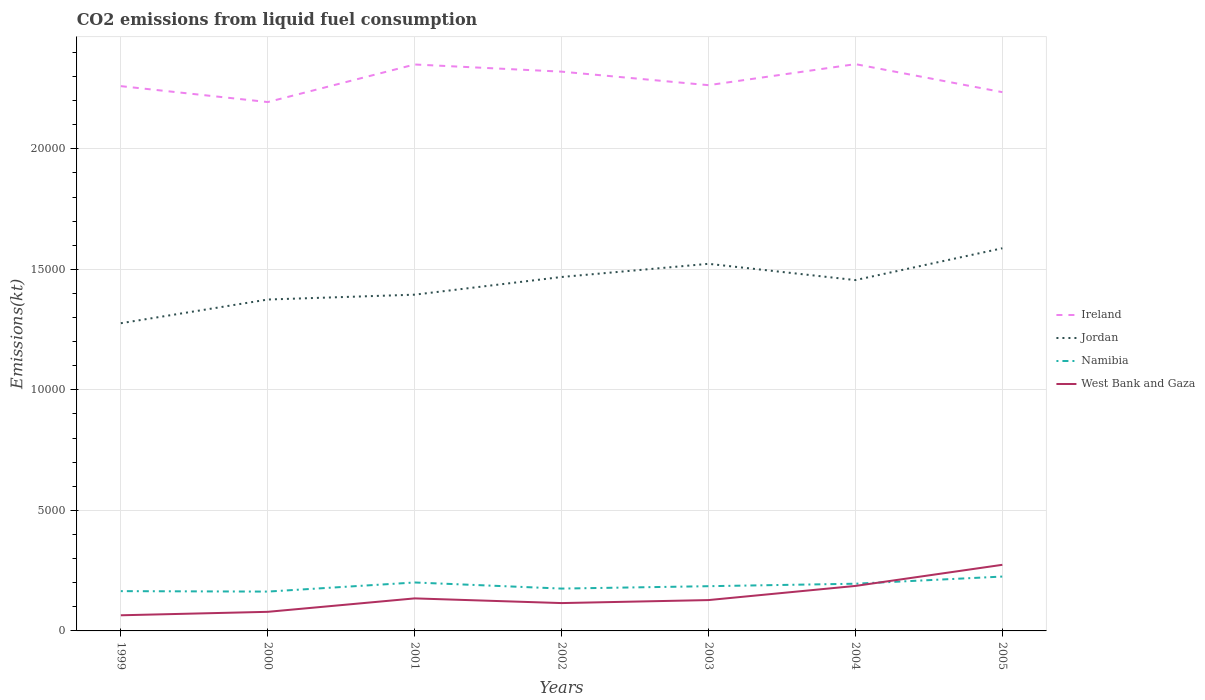How many different coloured lines are there?
Offer a terse response. 4. Does the line corresponding to Jordan intersect with the line corresponding to West Bank and Gaza?
Give a very brief answer. No. Across all years, what is the maximum amount of CO2 emitted in West Bank and Gaza?
Offer a very short reply. 649.06. In which year was the amount of CO2 emitted in Jordan maximum?
Offer a terse response. 1999. What is the total amount of CO2 emitted in Jordan in the graph?
Offer a terse response. -733.4. What is the difference between the highest and the second highest amount of CO2 emitted in Jordan?
Offer a very short reply. 3109.62. Is the amount of CO2 emitted in Namibia strictly greater than the amount of CO2 emitted in Jordan over the years?
Your answer should be compact. Yes. How many years are there in the graph?
Ensure brevity in your answer.  7. Where does the legend appear in the graph?
Offer a very short reply. Center right. How are the legend labels stacked?
Make the answer very short. Vertical. What is the title of the graph?
Ensure brevity in your answer.  CO2 emissions from liquid fuel consumption. What is the label or title of the X-axis?
Make the answer very short. Years. What is the label or title of the Y-axis?
Give a very brief answer. Emissions(kt). What is the Emissions(kt) in Ireland in 1999?
Offer a terse response. 2.26e+04. What is the Emissions(kt) in Jordan in 1999?
Your answer should be very brief. 1.28e+04. What is the Emissions(kt) in Namibia in 1999?
Ensure brevity in your answer.  1650.15. What is the Emissions(kt) in West Bank and Gaza in 1999?
Make the answer very short. 649.06. What is the Emissions(kt) in Ireland in 2000?
Give a very brief answer. 2.19e+04. What is the Emissions(kt) in Jordan in 2000?
Your answer should be very brief. 1.37e+04. What is the Emissions(kt) in Namibia in 2000?
Your answer should be very brief. 1631.82. What is the Emissions(kt) of West Bank and Gaza in 2000?
Give a very brief answer. 792.07. What is the Emissions(kt) in Ireland in 2001?
Provide a succinct answer. 2.35e+04. What is the Emissions(kt) in Jordan in 2001?
Offer a terse response. 1.39e+04. What is the Emissions(kt) of Namibia in 2001?
Give a very brief answer. 2009.52. What is the Emissions(kt) of West Bank and Gaza in 2001?
Offer a terse response. 1349.46. What is the Emissions(kt) of Ireland in 2002?
Provide a short and direct response. 2.32e+04. What is the Emissions(kt) in Jordan in 2002?
Your answer should be compact. 1.47e+04. What is the Emissions(kt) in Namibia in 2002?
Your answer should be compact. 1756.49. What is the Emissions(kt) of West Bank and Gaza in 2002?
Make the answer very short. 1155.11. What is the Emissions(kt) in Ireland in 2003?
Make the answer very short. 2.26e+04. What is the Emissions(kt) in Jordan in 2003?
Keep it short and to the point. 1.52e+04. What is the Emissions(kt) of Namibia in 2003?
Provide a short and direct response. 1855.5. What is the Emissions(kt) of West Bank and Gaza in 2003?
Your response must be concise. 1279.78. What is the Emissions(kt) of Ireland in 2004?
Offer a very short reply. 2.35e+04. What is the Emissions(kt) of Jordan in 2004?
Your answer should be compact. 1.46e+04. What is the Emissions(kt) in Namibia in 2004?
Your response must be concise. 1958.18. What is the Emissions(kt) of West Bank and Gaza in 2004?
Offer a very short reply. 1866.5. What is the Emissions(kt) of Ireland in 2005?
Provide a short and direct response. 2.24e+04. What is the Emissions(kt) of Jordan in 2005?
Ensure brevity in your answer.  1.59e+04. What is the Emissions(kt) of Namibia in 2005?
Keep it short and to the point. 2255.2. What is the Emissions(kt) in West Bank and Gaza in 2005?
Your response must be concise. 2742.92. Across all years, what is the maximum Emissions(kt) of Ireland?
Your response must be concise. 2.35e+04. Across all years, what is the maximum Emissions(kt) of Jordan?
Your answer should be very brief. 1.59e+04. Across all years, what is the maximum Emissions(kt) of Namibia?
Keep it short and to the point. 2255.2. Across all years, what is the maximum Emissions(kt) of West Bank and Gaza?
Your answer should be very brief. 2742.92. Across all years, what is the minimum Emissions(kt) in Ireland?
Offer a very short reply. 2.19e+04. Across all years, what is the minimum Emissions(kt) of Jordan?
Keep it short and to the point. 1.28e+04. Across all years, what is the minimum Emissions(kt) of Namibia?
Provide a succinct answer. 1631.82. Across all years, what is the minimum Emissions(kt) in West Bank and Gaza?
Your answer should be very brief. 649.06. What is the total Emissions(kt) of Ireland in the graph?
Provide a succinct answer. 1.60e+05. What is the total Emissions(kt) in Jordan in the graph?
Keep it short and to the point. 1.01e+05. What is the total Emissions(kt) of Namibia in the graph?
Ensure brevity in your answer.  1.31e+04. What is the total Emissions(kt) of West Bank and Gaza in the graph?
Your answer should be very brief. 9834.89. What is the difference between the Emissions(kt) of Ireland in 1999 and that in 2000?
Your response must be concise. 660.06. What is the difference between the Emissions(kt) in Jordan in 1999 and that in 2000?
Make the answer very short. -982.76. What is the difference between the Emissions(kt) in Namibia in 1999 and that in 2000?
Make the answer very short. 18.34. What is the difference between the Emissions(kt) of West Bank and Gaza in 1999 and that in 2000?
Offer a terse response. -143.01. What is the difference between the Emissions(kt) of Ireland in 1999 and that in 2001?
Ensure brevity in your answer.  -898.41. What is the difference between the Emissions(kt) in Jordan in 1999 and that in 2001?
Provide a succinct answer. -1184.44. What is the difference between the Emissions(kt) in Namibia in 1999 and that in 2001?
Offer a very short reply. -359.37. What is the difference between the Emissions(kt) of West Bank and Gaza in 1999 and that in 2001?
Ensure brevity in your answer.  -700.4. What is the difference between the Emissions(kt) of Ireland in 1999 and that in 2002?
Make the answer very short. -601.39. What is the difference between the Emissions(kt) of Jordan in 1999 and that in 2002?
Offer a very short reply. -1917.84. What is the difference between the Emissions(kt) of Namibia in 1999 and that in 2002?
Keep it short and to the point. -106.34. What is the difference between the Emissions(kt) of West Bank and Gaza in 1999 and that in 2002?
Your response must be concise. -506.05. What is the difference between the Emissions(kt) in Ireland in 1999 and that in 2003?
Make the answer very short. -40.34. What is the difference between the Emissions(kt) of Jordan in 1999 and that in 2003?
Offer a terse response. -2464.22. What is the difference between the Emissions(kt) of Namibia in 1999 and that in 2003?
Offer a terse response. -205.35. What is the difference between the Emissions(kt) of West Bank and Gaza in 1999 and that in 2003?
Offer a very short reply. -630.72. What is the difference between the Emissions(kt) in Ireland in 1999 and that in 2004?
Your response must be concise. -913.08. What is the difference between the Emissions(kt) of Jordan in 1999 and that in 2004?
Your answer should be compact. -1789.5. What is the difference between the Emissions(kt) of Namibia in 1999 and that in 2004?
Offer a terse response. -308.03. What is the difference between the Emissions(kt) of West Bank and Gaza in 1999 and that in 2004?
Ensure brevity in your answer.  -1217.44. What is the difference between the Emissions(kt) of Ireland in 1999 and that in 2005?
Your answer should be compact. 249.36. What is the difference between the Emissions(kt) in Jordan in 1999 and that in 2005?
Your answer should be very brief. -3109.62. What is the difference between the Emissions(kt) in Namibia in 1999 and that in 2005?
Make the answer very short. -605.05. What is the difference between the Emissions(kt) of West Bank and Gaza in 1999 and that in 2005?
Make the answer very short. -2093.86. What is the difference between the Emissions(kt) of Ireland in 2000 and that in 2001?
Offer a very short reply. -1558.47. What is the difference between the Emissions(kt) of Jordan in 2000 and that in 2001?
Your answer should be compact. -201.69. What is the difference between the Emissions(kt) of Namibia in 2000 and that in 2001?
Your answer should be compact. -377.7. What is the difference between the Emissions(kt) in West Bank and Gaza in 2000 and that in 2001?
Provide a succinct answer. -557.38. What is the difference between the Emissions(kt) in Ireland in 2000 and that in 2002?
Offer a terse response. -1261.45. What is the difference between the Emissions(kt) of Jordan in 2000 and that in 2002?
Provide a short and direct response. -935.09. What is the difference between the Emissions(kt) of Namibia in 2000 and that in 2002?
Offer a very short reply. -124.68. What is the difference between the Emissions(kt) in West Bank and Gaza in 2000 and that in 2002?
Ensure brevity in your answer.  -363.03. What is the difference between the Emissions(kt) in Ireland in 2000 and that in 2003?
Provide a succinct answer. -700.4. What is the difference between the Emissions(kt) in Jordan in 2000 and that in 2003?
Your response must be concise. -1481.47. What is the difference between the Emissions(kt) of Namibia in 2000 and that in 2003?
Keep it short and to the point. -223.69. What is the difference between the Emissions(kt) in West Bank and Gaza in 2000 and that in 2003?
Keep it short and to the point. -487.71. What is the difference between the Emissions(kt) in Ireland in 2000 and that in 2004?
Your answer should be very brief. -1573.14. What is the difference between the Emissions(kt) in Jordan in 2000 and that in 2004?
Keep it short and to the point. -806.74. What is the difference between the Emissions(kt) in Namibia in 2000 and that in 2004?
Provide a short and direct response. -326.36. What is the difference between the Emissions(kt) of West Bank and Gaza in 2000 and that in 2004?
Offer a very short reply. -1074.43. What is the difference between the Emissions(kt) in Ireland in 2000 and that in 2005?
Make the answer very short. -410.7. What is the difference between the Emissions(kt) in Jordan in 2000 and that in 2005?
Offer a terse response. -2126.86. What is the difference between the Emissions(kt) in Namibia in 2000 and that in 2005?
Your answer should be compact. -623.39. What is the difference between the Emissions(kt) of West Bank and Gaza in 2000 and that in 2005?
Offer a terse response. -1950.84. What is the difference between the Emissions(kt) in Ireland in 2001 and that in 2002?
Your response must be concise. 297.03. What is the difference between the Emissions(kt) in Jordan in 2001 and that in 2002?
Give a very brief answer. -733.4. What is the difference between the Emissions(kt) in Namibia in 2001 and that in 2002?
Keep it short and to the point. 253.02. What is the difference between the Emissions(kt) in West Bank and Gaza in 2001 and that in 2002?
Provide a succinct answer. 194.35. What is the difference between the Emissions(kt) in Ireland in 2001 and that in 2003?
Provide a succinct answer. 858.08. What is the difference between the Emissions(kt) in Jordan in 2001 and that in 2003?
Give a very brief answer. -1279.78. What is the difference between the Emissions(kt) of Namibia in 2001 and that in 2003?
Provide a succinct answer. 154.01. What is the difference between the Emissions(kt) in West Bank and Gaza in 2001 and that in 2003?
Give a very brief answer. 69.67. What is the difference between the Emissions(kt) in Ireland in 2001 and that in 2004?
Keep it short and to the point. -14.67. What is the difference between the Emissions(kt) in Jordan in 2001 and that in 2004?
Ensure brevity in your answer.  -605.05. What is the difference between the Emissions(kt) of Namibia in 2001 and that in 2004?
Your answer should be compact. 51.34. What is the difference between the Emissions(kt) in West Bank and Gaza in 2001 and that in 2004?
Provide a succinct answer. -517.05. What is the difference between the Emissions(kt) in Ireland in 2001 and that in 2005?
Keep it short and to the point. 1147.77. What is the difference between the Emissions(kt) in Jordan in 2001 and that in 2005?
Give a very brief answer. -1925.17. What is the difference between the Emissions(kt) of Namibia in 2001 and that in 2005?
Offer a very short reply. -245.69. What is the difference between the Emissions(kt) of West Bank and Gaza in 2001 and that in 2005?
Offer a very short reply. -1393.46. What is the difference between the Emissions(kt) in Ireland in 2002 and that in 2003?
Provide a succinct answer. 561.05. What is the difference between the Emissions(kt) of Jordan in 2002 and that in 2003?
Provide a succinct answer. -546.38. What is the difference between the Emissions(kt) in Namibia in 2002 and that in 2003?
Give a very brief answer. -99.01. What is the difference between the Emissions(kt) of West Bank and Gaza in 2002 and that in 2003?
Make the answer very short. -124.68. What is the difference between the Emissions(kt) of Ireland in 2002 and that in 2004?
Ensure brevity in your answer.  -311.69. What is the difference between the Emissions(kt) in Jordan in 2002 and that in 2004?
Provide a short and direct response. 128.34. What is the difference between the Emissions(kt) of Namibia in 2002 and that in 2004?
Your response must be concise. -201.69. What is the difference between the Emissions(kt) in West Bank and Gaza in 2002 and that in 2004?
Offer a terse response. -711.4. What is the difference between the Emissions(kt) of Ireland in 2002 and that in 2005?
Offer a terse response. 850.74. What is the difference between the Emissions(kt) of Jordan in 2002 and that in 2005?
Make the answer very short. -1191.78. What is the difference between the Emissions(kt) in Namibia in 2002 and that in 2005?
Your answer should be compact. -498.71. What is the difference between the Emissions(kt) in West Bank and Gaza in 2002 and that in 2005?
Your answer should be very brief. -1587.81. What is the difference between the Emissions(kt) of Ireland in 2003 and that in 2004?
Your answer should be very brief. -872.75. What is the difference between the Emissions(kt) of Jordan in 2003 and that in 2004?
Offer a very short reply. 674.73. What is the difference between the Emissions(kt) of Namibia in 2003 and that in 2004?
Offer a terse response. -102.68. What is the difference between the Emissions(kt) in West Bank and Gaza in 2003 and that in 2004?
Offer a very short reply. -586.72. What is the difference between the Emissions(kt) of Ireland in 2003 and that in 2005?
Offer a very short reply. 289.69. What is the difference between the Emissions(kt) in Jordan in 2003 and that in 2005?
Offer a very short reply. -645.39. What is the difference between the Emissions(kt) in Namibia in 2003 and that in 2005?
Give a very brief answer. -399.7. What is the difference between the Emissions(kt) of West Bank and Gaza in 2003 and that in 2005?
Provide a succinct answer. -1463.13. What is the difference between the Emissions(kt) in Ireland in 2004 and that in 2005?
Provide a short and direct response. 1162.44. What is the difference between the Emissions(kt) in Jordan in 2004 and that in 2005?
Give a very brief answer. -1320.12. What is the difference between the Emissions(kt) of Namibia in 2004 and that in 2005?
Offer a terse response. -297.03. What is the difference between the Emissions(kt) in West Bank and Gaza in 2004 and that in 2005?
Provide a succinct answer. -876.41. What is the difference between the Emissions(kt) in Ireland in 1999 and the Emissions(kt) in Jordan in 2000?
Ensure brevity in your answer.  8852.14. What is the difference between the Emissions(kt) in Ireland in 1999 and the Emissions(kt) in Namibia in 2000?
Provide a short and direct response. 2.10e+04. What is the difference between the Emissions(kt) of Ireland in 1999 and the Emissions(kt) of West Bank and Gaza in 2000?
Provide a short and direct response. 2.18e+04. What is the difference between the Emissions(kt) of Jordan in 1999 and the Emissions(kt) of Namibia in 2000?
Keep it short and to the point. 1.11e+04. What is the difference between the Emissions(kt) of Jordan in 1999 and the Emissions(kt) of West Bank and Gaza in 2000?
Your answer should be very brief. 1.20e+04. What is the difference between the Emissions(kt) in Namibia in 1999 and the Emissions(kt) in West Bank and Gaza in 2000?
Offer a terse response. 858.08. What is the difference between the Emissions(kt) of Ireland in 1999 and the Emissions(kt) of Jordan in 2001?
Provide a short and direct response. 8650.45. What is the difference between the Emissions(kt) of Ireland in 1999 and the Emissions(kt) of Namibia in 2001?
Provide a short and direct response. 2.06e+04. What is the difference between the Emissions(kt) in Ireland in 1999 and the Emissions(kt) in West Bank and Gaza in 2001?
Your answer should be very brief. 2.13e+04. What is the difference between the Emissions(kt) of Jordan in 1999 and the Emissions(kt) of Namibia in 2001?
Make the answer very short. 1.08e+04. What is the difference between the Emissions(kt) in Jordan in 1999 and the Emissions(kt) in West Bank and Gaza in 2001?
Offer a terse response. 1.14e+04. What is the difference between the Emissions(kt) in Namibia in 1999 and the Emissions(kt) in West Bank and Gaza in 2001?
Offer a terse response. 300.69. What is the difference between the Emissions(kt) of Ireland in 1999 and the Emissions(kt) of Jordan in 2002?
Offer a very short reply. 7917.05. What is the difference between the Emissions(kt) in Ireland in 1999 and the Emissions(kt) in Namibia in 2002?
Offer a very short reply. 2.08e+04. What is the difference between the Emissions(kt) in Ireland in 1999 and the Emissions(kt) in West Bank and Gaza in 2002?
Provide a succinct answer. 2.14e+04. What is the difference between the Emissions(kt) of Jordan in 1999 and the Emissions(kt) of Namibia in 2002?
Provide a succinct answer. 1.10e+04. What is the difference between the Emissions(kt) in Jordan in 1999 and the Emissions(kt) in West Bank and Gaza in 2002?
Offer a very short reply. 1.16e+04. What is the difference between the Emissions(kt) in Namibia in 1999 and the Emissions(kt) in West Bank and Gaza in 2002?
Keep it short and to the point. 495.05. What is the difference between the Emissions(kt) of Ireland in 1999 and the Emissions(kt) of Jordan in 2003?
Offer a very short reply. 7370.67. What is the difference between the Emissions(kt) in Ireland in 1999 and the Emissions(kt) in Namibia in 2003?
Keep it short and to the point. 2.07e+04. What is the difference between the Emissions(kt) of Ireland in 1999 and the Emissions(kt) of West Bank and Gaza in 2003?
Your response must be concise. 2.13e+04. What is the difference between the Emissions(kt) of Jordan in 1999 and the Emissions(kt) of Namibia in 2003?
Provide a succinct answer. 1.09e+04. What is the difference between the Emissions(kt) of Jordan in 1999 and the Emissions(kt) of West Bank and Gaza in 2003?
Make the answer very short. 1.15e+04. What is the difference between the Emissions(kt) of Namibia in 1999 and the Emissions(kt) of West Bank and Gaza in 2003?
Ensure brevity in your answer.  370.37. What is the difference between the Emissions(kt) of Ireland in 1999 and the Emissions(kt) of Jordan in 2004?
Make the answer very short. 8045.4. What is the difference between the Emissions(kt) of Ireland in 1999 and the Emissions(kt) of Namibia in 2004?
Offer a terse response. 2.06e+04. What is the difference between the Emissions(kt) in Ireland in 1999 and the Emissions(kt) in West Bank and Gaza in 2004?
Provide a succinct answer. 2.07e+04. What is the difference between the Emissions(kt) of Jordan in 1999 and the Emissions(kt) of Namibia in 2004?
Your answer should be compact. 1.08e+04. What is the difference between the Emissions(kt) of Jordan in 1999 and the Emissions(kt) of West Bank and Gaza in 2004?
Provide a succinct answer. 1.09e+04. What is the difference between the Emissions(kt) in Namibia in 1999 and the Emissions(kt) in West Bank and Gaza in 2004?
Ensure brevity in your answer.  -216.35. What is the difference between the Emissions(kt) of Ireland in 1999 and the Emissions(kt) of Jordan in 2005?
Keep it short and to the point. 6725.28. What is the difference between the Emissions(kt) of Ireland in 1999 and the Emissions(kt) of Namibia in 2005?
Ensure brevity in your answer.  2.03e+04. What is the difference between the Emissions(kt) of Ireland in 1999 and the Emissions(kt) of West Bank and Gaza in 2005?
Keep it short and to the point. 1.99e+04. What is the difference between the Emissions(kt) in Jordan in 1999 and the Emissions(kt) in Namibia in 2005?
Your answer should be very brief. 1.05e+04. What is the difference between the Emissions(kt) of Jordan in 1999 and the Emissions(kt) of West Bank and Gaza in 2005?
Ensure brevity in your answer.  1.00e+04. What is the difference between the Emissions(kt) of Namibia in 1999 and the Emissions(kt) of West Bank and Gaza in 2005?
Provide a succinct answer. -1092.77. What is the difference between the Emissions(kt) in Ireland in 2000 and the Emissions(kt) in Jordan in 2001?
Your response must be concise. 7990.39. What is the difference between the Emissions(kt) of Ireland in 2000 and the Emissions(kt) of Namibia in 2001?
Offer a very short reply. 1.99e+04. What is the difference between the Emissions(kt) in Ireland in 2000 and the Emissions(kt) in West Bank and Gaza in 2001?
Ensure brevity in your answer.  2.06e+04. What is the difference between the Emissions(kt) in Jordan in 2000 and the Emissions(kt) in Namibia in 2001?
Give a very brief answer. 1.17e+04. What is the difference between the Emissions(kt) of Jordan in 2000 and the Emissions(kt) of West Bank and Gaza in 2001?
Ensure brevity in your answer.  1.24e+04. What is the difference between the Emissions(kt) of Namibia in 2000 and the Emissions(kt) of West Bank and Gaza in 2001?
Ensure brevity in your answer.  282.36. What is the difference between the Emissions(kt) of Ireland in 2000 and the Emissions(kt) of Jordan in 2002?
Provide a short and direct response. 7256.99. What is the difference between the Emissions(kt) in Ireland in 2000 and the Emissions(kt) in Namibia in 2002?
Keep it short and to the point. 2.02e+04. What is the difference between the Emissions(kt) in Ireland in 2000 and the Emissions(kt) in West Bank and Gaza in 2002?
Your answer should be compact. 2.08e+04. What is the difference between the Emissions(kt) of Jordan in 2000 and the Emissions(kt) of Namibia in 2002?
Give a very brief answer. 1.20e+04. What is the difference between the Emissions(kt) of Jordan in 2000 and the Emissions(kt) of West Bank and Gaza in 2002?
Offer a terse response. 1.26e+04. What is the difference between the Emissions(kt) in Namibia in 2000 and the Emissions(kt) in West Bank and Gaza in 2002?
Make the answer very short. 476.71. What is the difference between the Emissions(kt) of Ireland in 2000 and the Emissions(kt) of Jordan in 2003?
Offer a terse response. 6710.61. What is the difference between the Emissions(kt) in Ireland in 2000 and the Emissions(kt) in Namibia in 2003?
Give a very brief answer. 2.01e+04. What is the difference between the Emissions(kt) in Ireland in 2000 and the Emissions(kt) in West Bank and Gaza in 2003?
Give a very brief answer. 2.07e+04. What is the difference between the Emissions(kt) in Jordan in 2000 and the Emissions(kt) in Namibia in 2003?
Give a very brief answer. 1.19e+04. What is the difference between the Emissions(kt) of Jordan in 2000 and the Emissions(kt) of West Bank and Gaza in 2003?
Provide a short and direct response. 1.25e+04. What is the difference between the Emissions(kt) in Namibia in 2000 and the Emissions(kt) in West Bank and Gaza in 2003?
Offer a very short reply. 352.03. What is the difference between the Emissions(kt) in Ireland in 2000 and the Emissions(kt) in Jordan in 2004?
Provide a succinct answer. 7385.34. What is the difference between the Emissions(kt) of Ireland in 2000 and the Emissions(kt) of Namibia in 2004?
Your answer should be compact. 2.00e+04. What is the difference between the Emissions(kt) of Ireland in 2000 and the Emissions(kt) of West Bank and Gaza in 2004?
Give a very brief answer. 2.01e+04. What is the difference between the Emissions(kt) of Jordan in 2000 and the Emissions(kt) of Namibia in 2004?
Provide a short and direct response. 1.18e+04. What is the difference between the Emissions(kt) in Jordan in 2000 and the Emissions(kt) in West Bank and Gaza in 2004?
Provide a succinct answer. 1.19e+04. What is the difference between the Emissions(kt) in Namibia in 2000 and the Emissions(kt) in West Bank and Gaza in 2004?
Offer a very short reply. -234.69. What is the difference between the Emissions(kt) in Ireland in 2000 and the Emissions(kt) in Jordan in 2005?
Ensure brevity in your answer.  6065.22. What is the difference between the Emissions(kt) of Ireland in 2000 and the Emissions(kt) of Namibia in 2005?
Keep it short and to the point. 1.97e+04. What is the difference between the Emissions(kt) of Ireland in 2000 and the Emissions(kt) of West Bank and Gaza in 2005?
Give a very brief answer. 1.92e+04. What is the difference between the Emissions(kt) in Jordan in 2000 and the Emissions(kt) in Namibia in 2005?
Your answer should be compact. 1.15e+04. What is the difference between the Emissions(kt) of Jordan in 2000 and the Emissions(kt) of West Bank and Gaza in 2005?
Your answer should be compact. 1.10e+04. What is the difference between the Emissions(kt) in Namibia in 2000 and the Emissions(kt) in West Bank and Gaza in 2005?
Make the answer very short. -1111.1. What is the difference between the Emissions(kt) in Ireland in 2001 and the Emissions(kt) in Jordan in 2002?
Make the answer very short. 8815.47. What is the difference between the Emissions(kt) in Ireland in 2001 and the Emissions(kt) in Namibia in 2002?
Your answer should be very brief. 2.17e+04. What is the difference between the Emissions(kt) of Ireland in 2001 and the Emissions(kt) of West Bank and Gaza in 2002?
Offer a terse response. 2.23e+04. What is the difference between the Emissions(kt) in Jordan in 2001 and the Emissions(kt) in Namibia in 2002?
Your answer should be very brief. 1.22e+04. What is the difference between the Emissions(kt) in Jordan in 2001 and the Emissions(kt) in West Bank and Gaza in 2002?
Your answer should be very brief. 1.28e+04. What is the difference between the Emissions(kt) in Namibia in 2001 and the Emissions(kt) in West Bank and Gaza in 2002?
Provide a short and direct response. 854.41. What is the difference between the Emissions(kt) in Ireland in 2001 and the Emissions(kt) in Jordan in 2003?
Give a very brief answer. 8269.08. What is the difference between the Emissions(kt) of Ireland in 2001 and the Emissions(kt) of Namibia in 2003?
Give a very brief answer. 2.16e+04. What is the difference between the Emissions(kt) of Ireland in 2001 and the Emissions(kt) of West Bank and Gaza in 2003?
Your answer should be compact. 2.22e+04. What is the difference between the Emissions(kt) of Jordan in 2001 and the Emissions(kt) of Namibia in 2003?
Ensure brevity in your answer.  1.21e+04. What is the difference between the Emissions(kt) of Jordan in 2001 and the Emissions(kt) of West Bank and Gaza in 2003?
Keep it short and to the point. 1.27e+04. What is the difference between the Emissions(kt) in Namibia in 2001 and the Emissions(kt) in West Bank and Gaza in 2003?
Offer a terse response. 729.73. What is the difference between the Emissions(kt) in Ireland in 2001 and the Emissions(kt) in Jordan in 2004?
Your answer should be compact. 8943.81. What is the difference between the Emissions(kt) of Ireland in 2001 and the Emissions(kt) of Namibia in 2004?
Make the answer very short. 2.15e+04. What is the difference between the Emissions(kt) in Ireland in 2001 and the Emissions(kt) in West Bank and Gaza in 2004?
Your response must be concise. 2.16e+04. What is the difference between the Emissions(kt) of Jordan in 2001 and the Emissions(kt) of Namibia in 2004?
Your answer should be compact. 1.20e+04. What is the difference between the Emissions(kt) of Jordan in 2001 and the Emissions(kt) of West Bank and Gaza in 2004?
Your answer should be very brief. 1.21e+04. What is the difference between the Emissions(kt) of Namibia in 2001 and the Emissions(kt) of West Bank and Gaza in 2004?
Give a very brief answer. 143.01. What is the difference between the Emissions(kt) of Ireland in 2001 and the Emissions(kt) of Jordan in 2005?
Your answer should be compact. 7623.69. What is the difference between the Emissions(kt) in Ireland in 2001 and the Emissions(kt) in Namibia in 2005?
Keep it short and to the point. 2.12e+04. What is the difference between the Emissions(kt) in Ireland in 2001 and the Emissions(kt) in West Bank and Gaza in 2005?
Your answer should be very brief. 2.08e+04. What is the difference between the Emissions(kt) of Jordan in 2001 and the Emissions(kt) of Namibia in 2005?
Your answer should be compact. 1.17e+04. What is the difference between the Emissions(kt) in Jordan in 2001 and the Emissions(kt) in West Bank and Gaza in 2005?
Give a very brief answer. 1.12e+04. What is the difference between the Emissions(kt) in Namibia in 2001 and the Emissions(kt) in West Bank and Gaza in 2005?
Provide a short and direct response. -733.4. What is the difference between the Emissions(kt) of Ireland in 2002 and the Emissions(kt) of Jordan in 2003?
Your answer should be very brief. 7972.06. What is the difference between the Emissions(kt) of Ireland in 2002 and the Emissions(kt) of Namibia in 2003?
Offer a terse response. 2.13e+04. What is the difference between the Emissions(kt) in Ireland in 2002 and the Emissions(kt) in West Bank and Gaza in 2003?
Provide a succinct answer. 2.19e+04. What is the difference between the Emissions(kt) in Jordan in 2002 and the Emissions(kt) in Namibia in 2003?
Ensure brevity in your answer.  1.28e+04. What is the difference between the Emissions(kt) in Jordan in 2002 and the Emissions(kt) in West Bank and Gaza in 2003?
Give a very brief answer. 1.34e+04. What is the difference between the Emissions(kt) in Namibia in 2002 and the Emissions(kt) in West Bank and Gaza in 2003?
Give a very brief answer. 476.71. What is the difference between the Emissions(kt) in Ireland in 2002 and the Emissions(kt) in Jordan in 2004?
Your response must be concise. 8646.79. What is the difference between the Emissions(kt) of Ireland in 2002 and the Emissions(kt) of Namibia in 2004?
Your answer should be compact. 2.12e+04. What is the difference between the Emissions(kt) in Ireland in 2002 and the Emissions(kt) in West Bank and Gaza in 2004?
Give a very brief answer. 2.13e+04. What is the difference between the Emissions(kt) of Jordan in 2002 and the Emissions(kt) of Namibia in 2004?
Offer a terse response. 1.27e+04. What is the difference between the Emissions(kt) of Jordan in 2002 and the Emissions(kt) of West Bank and Gaza in 2004?
Give a very brief answer. 1.28e+04. What is the difference between the Emissions(kt) of Namibia in 2002 and the Emissions(kt) of West Bank and Gaza in 2004?
Ensure brevity in your answer.  -110.01. What is the difference between the Emissions(kt) in Ireland in 2002 and the Emissions(kt) in Jordan in 2005?
Give a very brief answer. 7326.67. What is the difference between the Emissions(kt) in Ireland in 2002 and the Emissions(kt) in Namibia in 2005?
Provide a short and direct response. 2.09e+04. What is the difference between the Emissions(kt) of Ireland in 2002 and the Emissions(kt) of West Bank and Gaza in 2005?
Offer a very short reply. 2.05e+04. What is the difference between the Emissions(kt) in Jordan in 2002 and the Emissions(kt) in Namibia in 2005?
Ensure brevity in your answer.  1.24e+04. What is the difference between the Emissions(kt) in Jordan in 2002 and the Emissions(kt) in West Bank and Gaza in 2005?
Make the answer very short. 1.19e+04. What is the difference between the Emissions(kt) in Namibia in 2002 and the Emissions(kt) in West Bank and Gaza in 2005?
Ensure brevity in your answer.  -986.42. What is the difference between the Emissions(kt) of Ireland in 2003 and the Emissions(kt) of Jordan in 2004?
Your answer should be very brief. 8085.73. What is the difference between the Emissions(kt) in Ireland in 2003 and the Emissions(kt) in Namibia in 2004?
Offer a terse response. 2.07e+04. What is the difference between the Emissions(kt) of Ireland in 2003 and the Emissions(kt) of West Bank and Gaza in 2004?
Provide a short and direct response. 2.08e+04. What is the difference between the Emissions(kt) in Jordan in 2003 and the Emissions(kt) in Namibia in 2004?
Your answer should be compact. 1.33e+04. What is the difference between the Emissions(kt) in Jordan in 2003 and the Emissions(kt) in West Bank and Gaza in 2004?
Offer a very short reply. 1.34e+04. What is the difference between the Emissions(kt) in Namibia in 2003 and the Emissions(kt) in West Bank and Gaza in 2004?
Offer a terse response. -11. What is the difference between the Emissions(kt) of Ireland in 2003 and the Emissions(kt) of Jordan in 2005?
Provide a succinct answer. 6765.61. What is the difference between the Emissions(kt) of Ireland in 2003 and the Emissions(kt) of Namibia in 2005?
Give a very brief answer. 2.04e+04. What is the difference between the Emissions(kt) in Ireland in 2003 and the Emissions(kt) in West Bank and Gaza in 2005?
Your response must be concise. 1.99e+04. What is the difference between the Emissions(kt) of Jordan in 2003 and the Emissions(kt) of Namibia in 2005?
Provide a short and direct response. 1.30e+04. What is the difference between the Emissions(kt) of Jordan in 2003 and the Emissions(kt) of West Bank and Gaza in 2005?
Your answer should be very brief. 1.25e+04. What is the difference between the Emissions(kt) of Namibia in 2003 and the Emissions(kt) of West Bank and Gaza in 2005?
Provide a short and direct response. -887.41. What is the difference between the Emissions(kt) of Ireland in 2004 and the Emissions(kt) of Jordan in 2005?
Provide a short and direct response. 7638.36. What is the difference between the Emissions(kt) of Ireland in 2004 and the Emissions(kt) of Namibia in 2005?
Keep it short and to the point. 2.13e+04. What is the difference between the Emissions(kt) of Ireland in 2004 and the Emissions(kt) of West Bank and Gaza in 2005?
Offer a terse response. 2.08e+04. What is the difference between the Emissions(kt) in Jordan in 2004 and the Emissions(kt) in Namibia in 2005?
Provide a succinct answer. 1.23e+04. What is the difference between the Emissions(kt) of Jordan in 2004 and the Emissions(kt) of West Bank and Gaza in 2005?
Ensure brevity in your answer.  1.18e+04. What is the difference between the Emissions(kt) in Namibia in 2004 and the Emissions(kt) in West Bank and Gaza in 2005?
Provide a short and direct response. -784.74. What is the average Emissions(kt) in Ireland per year?
Provide a short and direct response. 2.28e+04. What is the average Emissions(kt) of Jordan per year?
Your response must be concise. 1.44e+04. What is the average Emissions(kt) of Namibia per year?
Offer a very short reply. 1873.84. What is the average Emissions(kt) of West Bank and Gaza per year?
Offer a very short reply. 1404.98. In the year 1999, what is the difference between the Emissions(kt) of Ireland and Emissions(kt) of Jordan?
Your answer should be very brief. 9834.89. In the year 1999, what is the difference between the Emissions(kt) of Ireland and Emissions(kt) of Namibia?
Give a very brief answer. 2.09e+04. In the year 1999, what is the difference between the Emissions(kt) of Ireland and Emissions(kt) of West Bank and Gaza?
Offer a very short reply. 2.20e+04. In the year 1999, what is the difference between the Emissions(kt) in Jordan and Emissions(kt) in Namibia?
Your answer should be very brief. 1.11e+04. In the year 1999, what is the difference between the Emissions(kt) in Jordan and Emissions(kt) in West Bank and Gaza?
Give a very brief answer. 1.21e+04. In the year 1999, what is the difference between the Emissions(kt) of Namibia and Emissions(kt) of West Bank and Gaza?
Your response must be concise. 1001.09. In the year 2000, what is the difference between the Emissions(kt) in Ireland and Emissions(kt) in Jordan?
Ensure brevity in your answer.  8192.08. In the year 2000, what is the difference between the Emissions(kt) in Ireland and Emissions(kt) in Namibia?
Your response must be concise. 2.03e+04. In the year 2000, what is the difference between the Emissions(kt) in Ireland and Emissions(kt) in West Bank and Gaza?
Ensure brevity in your answer.  2.11e+04. In the year 2000, what is the difference between the Emissions(kt) in Jordan and Emissions(kt) in Namibia?
Keep it short and to the point. 1.21e+04. In the year 2000, what is the difference between the Emissions(kt) in Jordan and Emissions(kt) in West Bank and Gaza?
Provide a short and direct response. 1.30e+04. In the year 2000, what is the difference between the Emissions(kt) of Namibia and Emissions(kt) of West Bank and Gaza?
Provide a succinct answer. 839.74. In the year 2001, what is the difference between the Emissions(kt) in Ireland and Emissions(kt) in Jordan?
Your response must be concise. 9548.87. In the year 2001, what is the difference between the Emissions(kt) of Ireland and Emissions(kt) of Namibia?
Your answer should be very brief. 2.15e+04. In the year 2001, what is the difference between the Emissions(kt) in Ireland and Emissions(kt) in West Bank and Gaza?
Give a very brief answer. 2.21e+04. In the year 2001, what is the difference between the Emissions(kt) of Jordan and Emissions(kt) of Namibia?
Offer a terse response. 1.19e+04. In the year 2001, what is the difference between the Emissions(kt) of Jordan and Emissions(kt) of West Bank and Gaza?
Provide a short and direct response. 1.26e+04. In the year 2001, what is the difference between the Emissions(kt) of Namibia and Emissions(kt) of West Bank and Gaza?
Ensure brevity in your answer.  660.06. In the year 2002, what is the difference between the Emissions(kt) in Ireland and Emissions(kt) in Jordan?
Ensure brevity in your answer.  8518.44. In the year 2002, what is the difference between the Emissions(kt) in Ireland and Emissions(kt) in Namibia?
Offer a terse response. 2.14e+04. In the year 2002, what is the difference between the Emissions(kt) of Ireland and Emissions(kt) of West Bank and Gaza?
Ensure brevity in your answer.  2.20e+04. In the year 2002, what is the difference between the Emissions(kt) of Jordan and Emissions(kt) of Namibia?
Make the answer very short. 1.29e+04. In the year 2002, what is the difference between the Emissions(kt) of Jordan and Emissions(kt) of West Bank and Gaza?
Your response must be concise. 1.35e+04. In the year 2002, what is the difference between the Emissions(kt) of Namibia and Emissions(kt) of West Bank and Gaza?
Ensure brevity in your answer.  601.39. In the year 2003, what is the difference between the Emissions(kt) of Ireland and Emissions(kt) of Jordan?
Provide a short and direct response. 7411.01. In the year 2003, what is the difference between the Emissions(kt) in Ireland and Emissions(kt) in Namibia?
Keep it short and to the point. 2.08e+04. In the year 2003, what is the difference between the Emissions(kt) of Ireland and Emissions(kt) of West Bank and Gaza?
Your answer should be very brief. 2.14e+04. In the year 2003, what is the difference between the Emissions(kt) in Jordan and Emissions(kt) in Namibia?
Offer a terse response. 1.34e+04. In the year 2003, what is the difference between the Emissions(kt) of Jordan and Emissions(kt) of West Bank and Gaza?
Your answer should be compact. 1.39e+04. In the year 2003, what is the difference between the Emissions(kt) of Namibia and Emissions(kt) of West Bank and Gaza?
Provide a short and direct response. 575.72. In the year 2004, what is the difference between the Emissions(kt) in Ireland and Emissions(kt) in Jordan?
Provide a succinct answer. 8958.48. In the year 2004, what is the difference between the Emissions(kt) in Ireland and Emissions(kt) in Namibia?
Your answer should be compact. 2.16e+04. In the year 2004, what is the difference between the Emissions(kt) of Ireland and Emissions(kt) of West Bank and Gaza?
Your answer should be compact. 2.16e+04. In the year 2004, what is the difference between the Emissions(kt) of Jordan and Emissions(kt) of Namibia?
Your answer should be compact. 1.26e+04. In the year 2004, what is the difference between the Emissions(kt) of Jordan and Emissions(kt) of West Bank and Gaza?
Offer a very short reply. 1.27e+04. In the year 2004, what is the difference between the Emissions(kt) in Namibia and Emissions(kt) in West Bank and Gaza?
Your answer should be compact. 91.67. In the year 2005, what is the difference between the Emissions(kt) in Ireland and Emissions(kt) in Jordan?
Make the answer very short. 6475.92. In the year 2005, what is the difference between the Emissions(kt) of Ireland and Emissions(kt) of Namibia?
Provide a succinct answer. 2.01e+04. In the year 2005, what is the difference between the Emissions(kt) in Ireland and Emissions(kt) in West Bank and Gaza?
Your answer should be very brief. 1.96e+04. In the year 2005, what is the difference between the Emissions(kt) in Jordan and Emissions(kt) in Namibia?
Provide a succinct answer. 1.36e+04. In the year 2005, what is the difference between the Emissions(kt) in Jordan and Emissions(kt) in West Bank and Gaza?
Provide a succinct answer. 1.31e+04. In the year 2005, what is the difference between the Emissions(kt) of Namibia and Emissions(kt) of West Bank and Gaza?
Your answer should be compact. -487.71. What is the ratio of the Emissions(kt) of Ireland in 1999 to that in 2000?
Provide a short and direct response. 1.03. What is the ratio of the Emissions(kt) in Jordan in 1999 to that in 2000?
Keep it short and to the point. 0.93. What is the ratio of the Emissions(kt) of Namibia in 1999 to that in 2000?
Ensure brevity in your answer.  1.01. What is the ratio of the Emissions(kt) in West Bank and Gaza in 1999 to that in 2000?
Your answer should be very brief. 0.82. What is the ratio of the Emissions(kt) of Ireland in 1999 to that in 2001?
Make the answer very short. 0.96. What is the ratio of the Emissions(kt) of Jordan in 1999 to that in 2001?
Provide a short and direct response. 0.92. What is the ratio of the Emissions(kt) in Namibia in 1999 to that in 2001?
Your answer should be compact. 0.82. What is the ratio of the Emissions(kt) in West Bank and Gaza in 1999 to that in 2001?
Your response must be concise. 0.48. What is the ratio of the Emissions(kt) in Ireland in 1999 to that in 2002?
Your response must be concise. 0.97. What is the ratio of the Emissions(kt) in Jordan in 1999 to that in 2002?
Keep it short and to the point. 0.87. What is the ratio of the Emissions(kt) in Namibia in 1999 to that in 2002?
Offer a terse response. 0.94. What is the ratio of the Emissions(kt) of West Bank and Gaza in 1999 to that in 2002?
Make the answer very short. 0.56. What is the ratio of the Emissions(kt) in Ireland in 1999 to that in 2003?
Keep it short and to the point. 1. What is the ratio of the Emissions(kt) in Jordan in 1999 to that in 2003?
Offer a very short reply. 0.84. What is the ratio of the Emissions(kt) of Namibia in 1999 to that in 2003?
Your answer should be compact. 0.89. What is the ratio of the Emissions(kt) of West Bank and Gaza in 1999 to that in 2003?
Keep it short and to the point. 0.51. What is the ratio of the Emissions(kt) in Ireland in 1999 to that in 2004?
Offer a very short reply. 0.96. What is the ratio of the Emissions(kt) of Jordan in 1999 to that in 2004?
Keep it short and to the point. 0.88. What is the ratio of the Emissions(kt) in Namibia in 1999 to that in 2004?
Offer a terse response. 0.84. What is the ratio of the Emissions(kt) of West Bank and Gaza in 1999 to that in 2004?
Your response must be concise. 0.35. What is the ratio of the Emissions(kt) of Ireland in 1999 to that in 2005?
Keep it short and to the point. 1.01. What is the ratio of the Emissions(kt) in Jordan in 1999 to that in 2005?
Make the answer very short. 0.8. What is the ratio of the Emissions(kt) of Namibia in 1999 to that in 2005?
Keep it short and to the point. 0.73. What is the ratio of the Emissions(kt) in West Bank and Gaza in 1999 to that in 2005?
Make the answer very short. 0.24. What is the ratio of the Emissions(kt) in Ireland in 2000 to that in 2001?
Make the answer very short. 0.93. What is the ratio of the Emissions(kt) of Jordan in 2000 to that in 2001?
Give a very brief answer. 0.99. What is the ratio of the Emissions(kt) in Namibia in 2000 to that in 2001?
Give a very brief answer. 0.81. What is the ratio of the Emissions(kt) in West Bank and Gaza in 2000 to that in 2001?
Make the answer very short. 0.59. What is the ratio of the Emissions(kt) of Ireland in 2000 to that in 2002?
Your response must be concise. 0.95. What is the ratio of the Emissions(kt) in Jordan in 2000 to that in 2002?
Your answer should be compact. 0.94. What is the ratio of the Emissions(kt) of Namibia in 2000 to that in 2002?
Give a very brief answer. 0.93. What is the ratio of the Emissions(kt) of West Bank and Gaza in 2000 to that in 2002?
Keep it short and to the point. 0.69. What is the ratio of the Emissions(kt) in Ireland in 2000 to that in 2003?
Your answer should be very brief. 0.97. What is the ratio of the Emissions(kt) of Jordan in 2000 to that in 2003?
Provide a short and direct response. 0.9. What is the ratio of the Emissions(kt) of Namibia in 2000 to that in 2003?
Give a very brief answer. 0.88. What is the ratio of the Emissions(kt) of West Bank and Gaza in 2000 to that in 2003?
Ensure brevity in your answer.  0.62. What is the ratio of the Emissions(kt) of Ireland in 2000 to that in 2004?
Make the answer very short. 0.93. What is the ratio of the Emissions(kt) in Jordan in 2000 to that in 2004?
Keep it short and to the point. 0.94. What is the ratio of the Emissions(kt) of West Bank and Gaza in 2000 to that in 2004?
Provide a short and direct response. 0.42. What is the ratio of the Emissions(kt) of Ireland in 2000 to that in 2005?
Offer a terse response. 0.98. What is the ratio of the Emissions(kt) of Jordan in 2000 to that in 2005?
Keep it short and to the point. 0.87. What is the ratio of the Emissions(kt) of Namibia in 2000 to that in 2005?
Give a very brief answer. 0.72. What is the ratio of the Emissions(kt) of West Bank and Gaza in 2000 to that in 2005?
Give a very brief answer. 0.29. What is the ratio of the Emissions(kt) of Ireland in 2001 to that in 2002?
Provide a succinct answer. 1.01. What is the ratio of the Emissions(kt) in Namibia in 2001 to that in 2002?
Keep it short and to the point. 1.14. What is the ratio of the Emissions(kt) of West Bank and Gaza in 2001 to that in 2002?
Offer a terse response. 1.17. What is the ratio of the Emissions(kt) of Ireland in 2001 to that in 2003?
Provide a short and direct response. 1.04. What is the ratio of the Emissions(kt) in Jordan in 2001 to that in 2003?
Provide a short and direct response. 0.92. What is the ratio of the Emissions(kt) of Namibia in 2001 to that in 2003?
Keep it short and to the point. 1.08. What is the ratio of the Emissions(kt) of West Bank and Gaza in 2001 to that in 2003?
Offer a very short reply. 1.05. What is the ratio of the Emissions(kt) in Ireland in 2001 to that in 2004?
Provide a short and direct response. 1. What is the ratio of the Emissions(kt) of Jordan in 2001 to that in 2004?
Provide a short and direct response. 0.96. What is the ratio of the Emissions(kt) in Namibia in 2001 to that in 2004?
Offer a very short reply. 1.03. What is the ratio of the Emissions(kt) of West Bank and Gaza in 2001 to that in 2004?
Your response must be concise. 0.72. What is the ratio of the Emissions(kt) in Ireland in 2001 to that in 2005?
Offer a very short reply. 1.05. What is the ratio of the Emissions(kt) of Jordan in 2001 to that in 2005?
Offer a terse response. 0.88. What is the ratio of the Emissions(kt) of Namibia in 2001 to that in 2005?
Keep it short and to the point. 0.89. What is the ratio of the Emissions(kt) of West Bank and Gaza in 2001 to that in 2005?
Your response must be concise. 0.49. What is the ratio of the Emissions(kt) in Ireland in 2002 to that in 2003?
Give a very brief answer. 1.02. What is the ratio of the Emissions(kt) in Jordan in 2002 to that in 2003?
Provide a succinct answer. 0.96. What is the ratio of the Emissions(kt) of Namibia in 2002 to that in 2003?
Offer a terse response. 0.95. What is the ratio of the Emissions(kt) in West Bank and Gaza in 2002 to that in 2003?
Provide a succinct answer. 0.9. What is the ratio of the Emissions(kt) of Ireland in 2002 to that in 2004?
Ensure brevity in your answer.  0.99. What is the ratio of the Emissions(kt) in Jordan in 2002 to that in 2004?
Give a very brief answer. 1.01. What is the ratio of the Emissions(kt) of Namibia in 2002 to that in 2004?
Your answer should be very brief. 0.9. What is the ratio of the Emissions(kt) of West Bank and Gaza in 2002 to that in 2004?
Offer a terse response. 0.62. What is the ratio of the Emissions(kt) in Ireland in 2002 to that in 2005?
Ensure brevity in your answer.  1.04. What is the ratio of the Emissions(kt) in Jordan in 2002 to that in 2005?
Give a very brief answer. 0.92. What is the ratio of the Emissions(kt) in Namibia in 2002 to that in 2005?
Make the answer very short. 0.78. What is the ratio of the Emissions(kt) of West Bank and Gaza in 2002 to that in 2005?
Make the answer very short. 0.42. What is the ratio of the Emissions(kt) in Ireland in 2003 to that in 2004?
Provide a succinct answer. 0.96. What is the ratio of the Emissions(kt) in Jordan in 2003 to that in 2004?
Provide a short and direct response. 1.05. What is the ratio of the Emissions(kt) in Namibia in 2003 to that in 2004?
Keep it short and to the point. 0.95. What is the ratio of the Emissions(kt) in West Bank and Gaza in 2003 to that in 2004?
Offer a very short reply. 0.69. What is the ratio of the Emissions(kt) of Ireland in 2003 to that in 2005?
Provide a short and direct response. 1.01. What is the ratio of the Emissions(kt) of Jordan in 2003 to that in 2005?
Keep it short and to the point. 0.96. What is the ratio of the Emissions(kt) of Namibia in 2003 to that in 2005?
Your answer should be very brief. 0.82. What is the ratio of the Emissions(kt) of West Bank and Gaza in 2003 to that in 2005?
Your response must be concise. 0.47. What is the ratio of the Emissions(kt) of Ireland in 2004 to that in 2005?
Offer a very short reply. 1.05. What is the ratio of the Emissions(kt) in Jordan in 2004 to that in 2005?
Offer a very short reply. 0.92. What is the ratio of the Emissions(kt) of Namibia in 2004 to that in 2005?
Make the answer very short. 0.87. What is the ratio of the Emissions(kt) of West Bank and Gaza in 2004 to that in 2005?
Keep it short and to the point. 0.68. What is the difference between the highest and the second highest Emissions(kt) of Ireland?
Give a very brief answer. 14.67. What is the difference between the highest and the second highest Emissions(kt) in Jordan?
Provide a short and direct response. 645.39. What is the difference between the highest and the second highest Emissions(kt) in Namibia?
Give a very brief answer. 245.69. What is the difference between the highest and the second highest Emissions(kt) in West Bank and Gaza?
Offer a terse response. 876.41. What is the difference between the highest and the lowest Emissions(kt) of Ireland?
Offer a terse response. 1573.14. What is the difference between the highest and the lowest Emissions(kt) in Jordan?
Give a very brief answer. 3109.62. What is the difference between the highest and the lowest Emissions(kt) of Namibia?
Your answer should be very brief. 623.39. What is the difference between the highest and the lowest Emissions(kt) of West Bank and Gaza?
Give a very brief answer. 2093.86. 